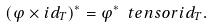<formula> <loc_0><loc_0><loc_500><loc_500>( \varphi \times i d _ { T } ) ^ { * } = \varphi ^ { * } \ t e n s o r i d _ { T } .</formula> 